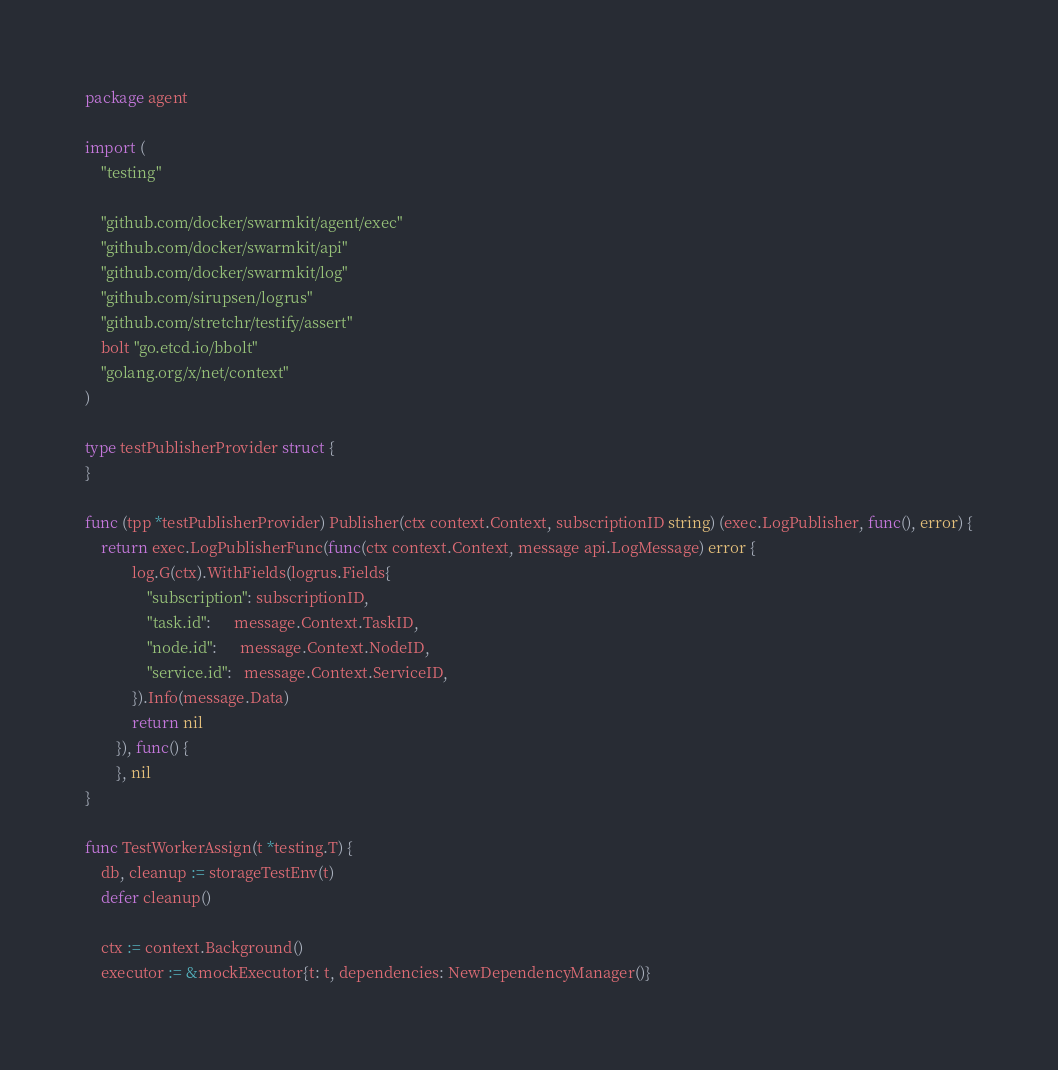<code> <loc_0><loc_0><loc_500><loc_500><_Go_>package agent

import (
	"testing"

	"github.com/docker/swarmkit/agent/exec"
	"github.com/docker/swarmkit/api"
	"github.com/docker/swarmkit/log"
	"github.com/sirupsen/logrus"
	"github.com/stretchr/testify/assert"
	bolt "go.etcd.io/bbolt"
	"golang.org/x/net/context"
)

type testPublisherProvider struct {
}

func (tpp *testPublisherProvider) Publisher(ctx context.Context, subscriptionID string) (exec.LogPublisher, func(), error) {
	return exec.LogPublisherFunc(func(ctx context.Context, message api.LogMessage) error {
			log.G(ctx).WithFields(logrus.Fields{
				"subscription": subscriptionID,
				"task.id":      message.Context.TaskID,
				"node.id":      message.Context.NodeID,
				"service.id":   message.Context.ServiceID,
			}).Info(message.Data)
			return nil
		}), func() {
		}, nil
}

func TestWorkerAssign(t *testing.T) {
	db, cleanup := storageTestEnv(t)
	defer cleanup()

	ctx := context.Background()
	executor := &mockExecutor{t: t, dependencies: NewDependencyManager()}</code> 